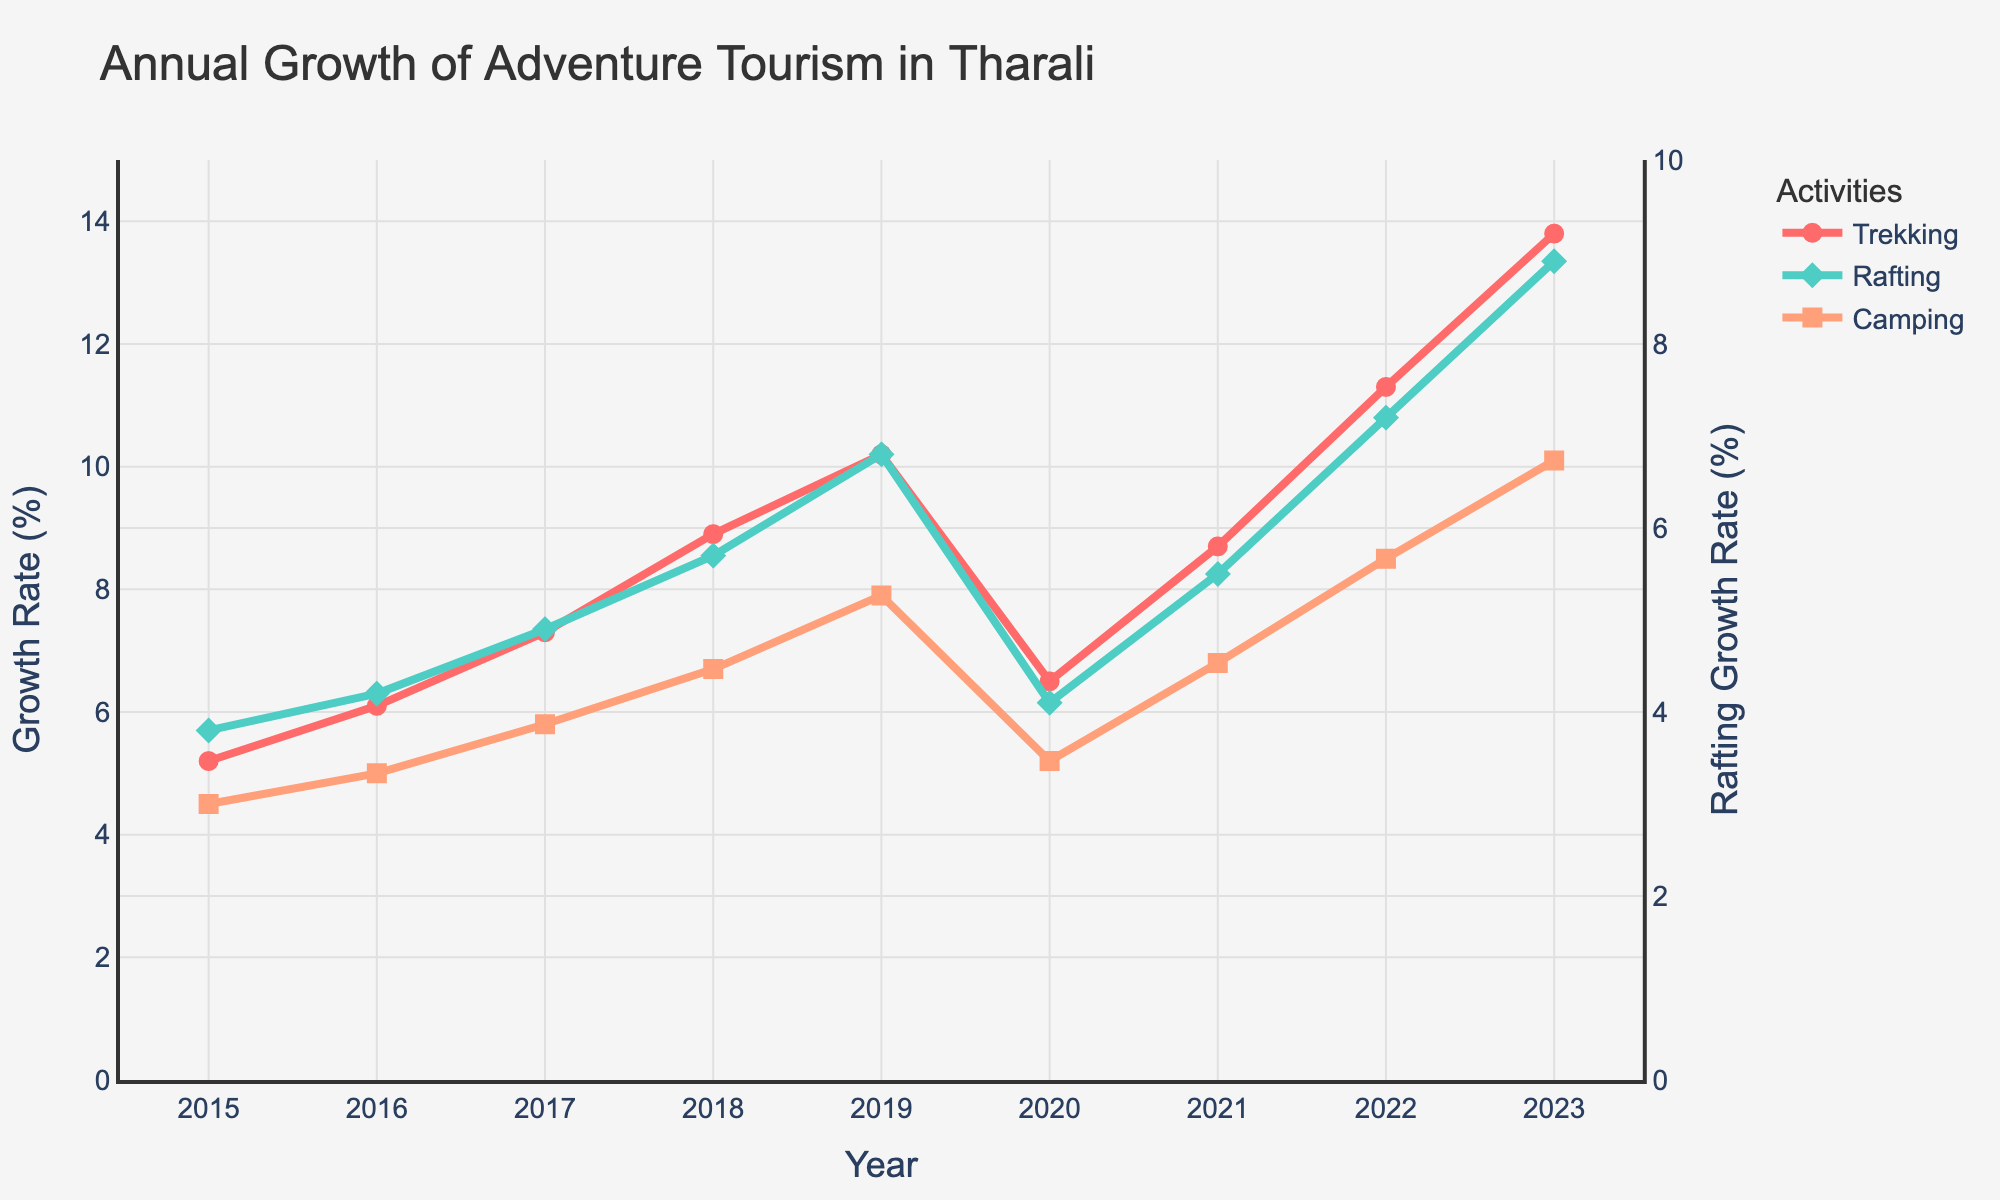What is the general trend of trekking activity between 2015 and 2023? The values for trekking show a generally increasing trend over the years, starting at 5.2% in 2015 and rising to 13.8% in 2023.
Answer: Increasing trend How did rafting activities change from 2019 to 2020? Rafting activities decreased from 6.8% in 2019 to 4.1% in 2020.
Answer: Decreased In which year did camping activity first surpass 8.0%? Camping activity first surpassed 8.0% in 2022 with a value of 8.5%.
Answer: 2022 What is the difference in trekking growth rate between the years 2019 and 2023? The trekking growth rate in 2019 was 10.2%, and in 2023 it was 13.8%. The difference is 13.8% - 10.2% = 3.6%.
Answer: 3.6% Which activity had the steepest growth between 2015 and 2023? Observing the slopes of the lines, trekking had the steepest growth from 5.2% in 2015 to 13.8% in 2023.
Answer: Trekking Did rafting ever surpass the camping growth rate, and if so, in which year? Rafting surpassed the camping growth rate in 2020, with rafting at 4.1% and camping at 5.2%.
Answer: No When did all activities face a noticeable dip in growth rate? All activities had a noticeable dip in growth rate in the year 2020.
Answer: 2020 What is the cumulative growth rate of trekking and camping in 2023? The growth rate for trekking in 2023 is 13.8% and for camping, it's 10.1%. The cumulative growth rate is 13.8% + 10.1% = 23.9%.
Answer: 23.9% How does the growth trend of rafting from 2021 to 2023 compare to the trend from 2015 to 2017? From 2021 to 2023, rafting increased from 5.5% to 8.9%. From 2015 to 2017, rafting increased from 3.8% to 4.9%. The trend from 2021 to 2023 shows a steeper growth rate compared to 2015 to 2017.
Answer: Steeper growth rate in 2021-2023 